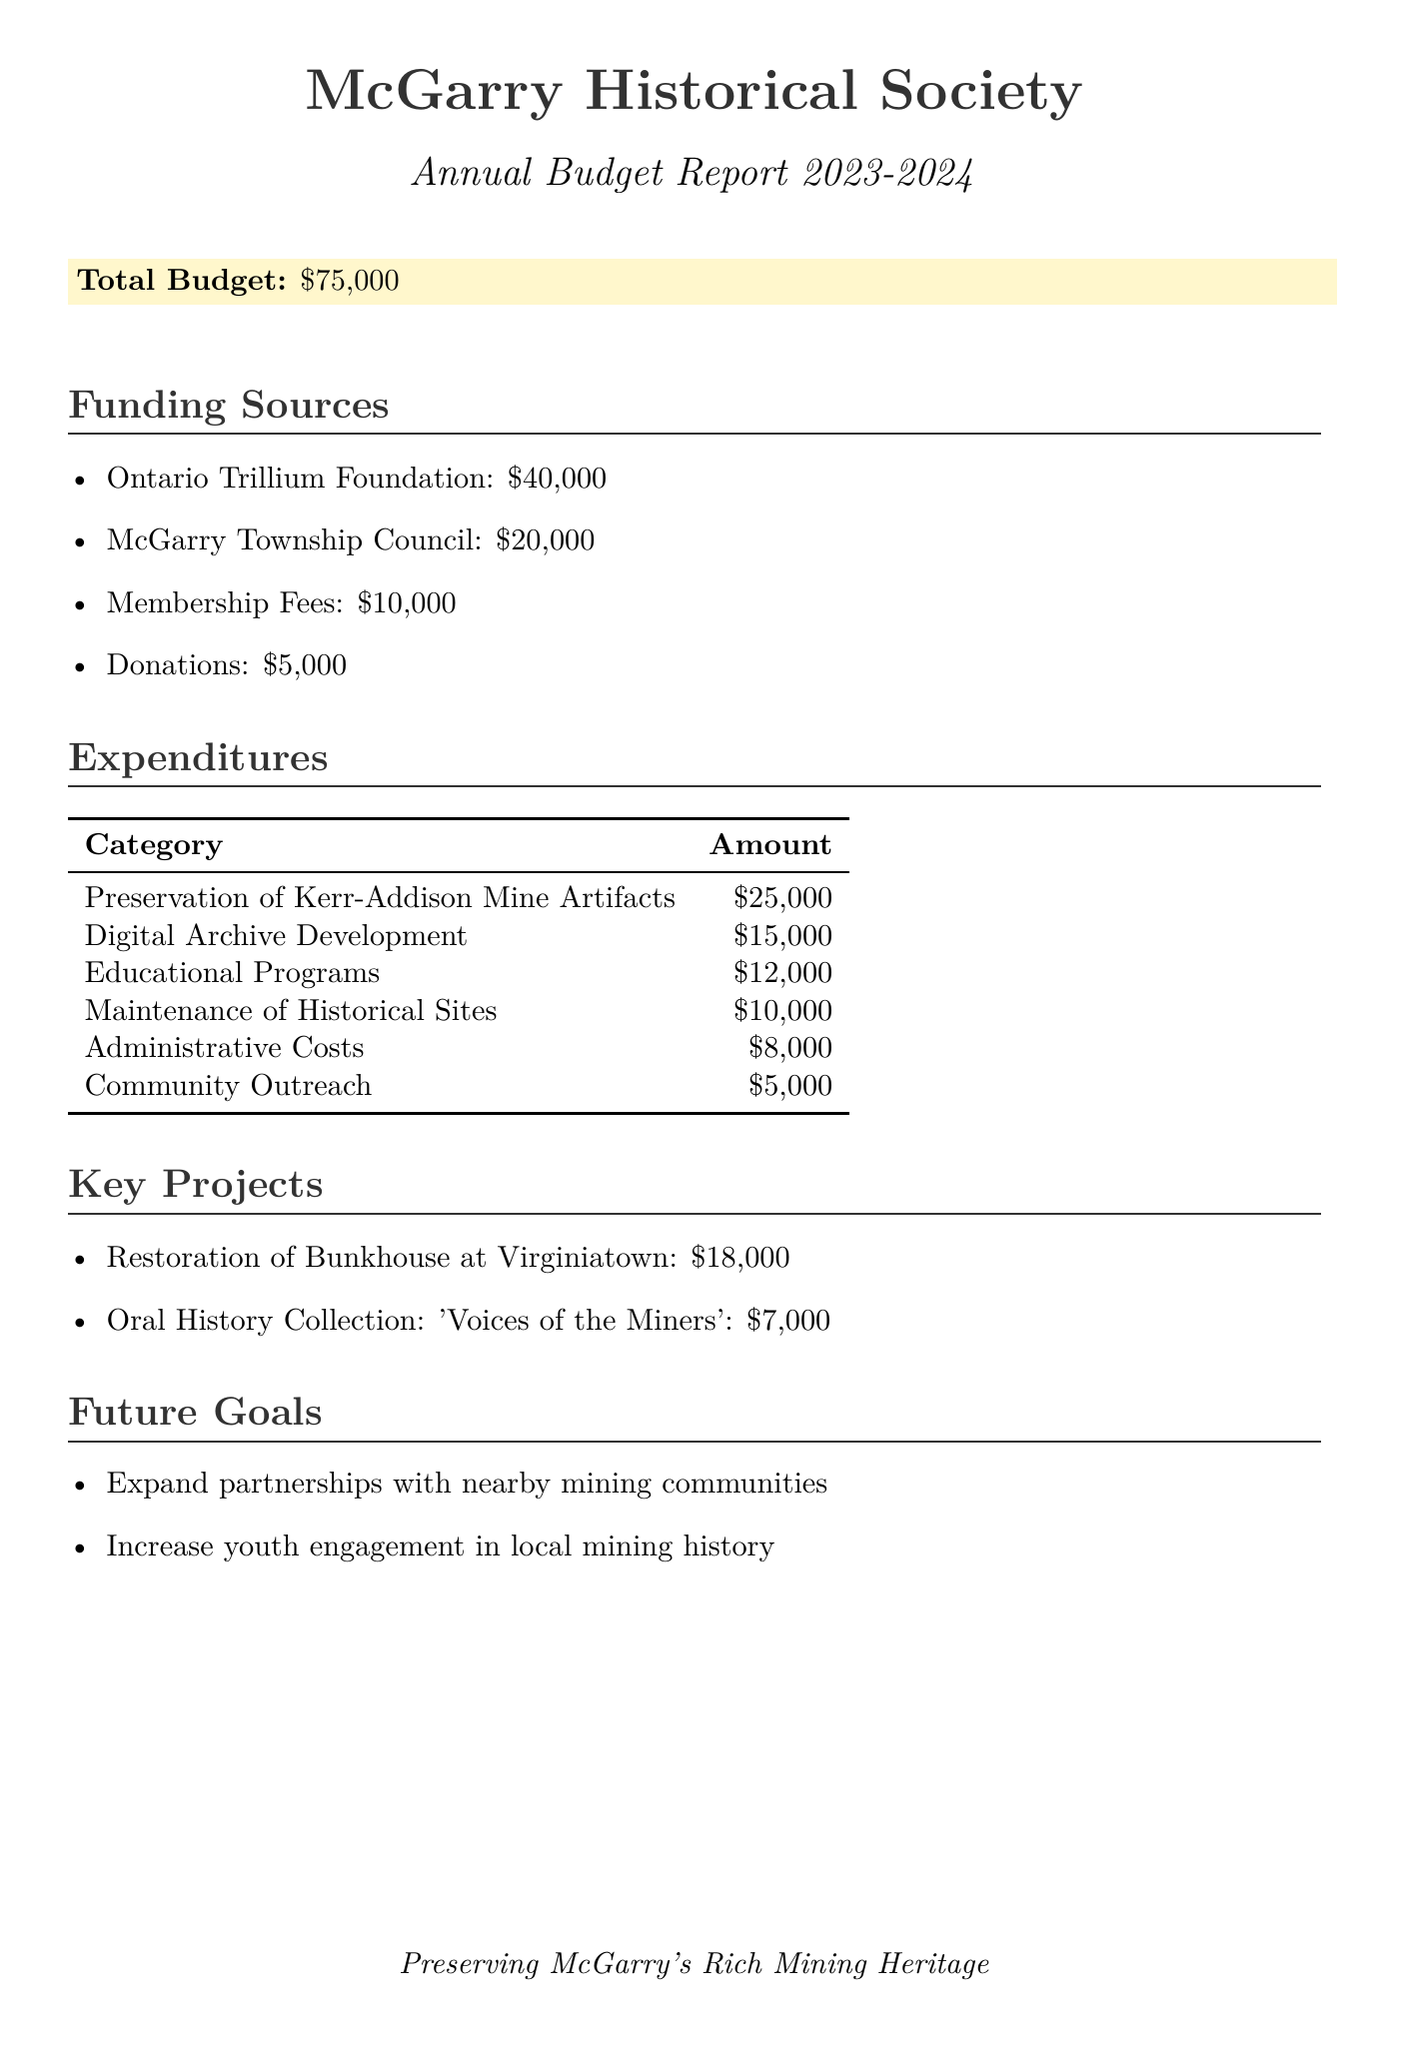What is the total budget? The total budget is stated at the beginning of the document as $75,000.
Answer: $75,000 How much does the Ontario Trillium Foundation contribute? The Ontario Trillium Foundation's contribution is detailed in the funding sources section.
Answer: $40,000 What is allocated for the Preservation of Kerr-Addison Mine Artifacts? The expenditure for preservation work can be found in the expenditures table.
Answer: $25,000 What is the budget for the restoration of the Bunkhouse at Virginiatown? This amount is specified under the key projects section in the document.
Answer: $18,000 How much is planned for Educational Programs? The amount for educational programs is listed in the expenditures section.
Answer: $12,000 What is one of the future goals mentioned? The future goals section includes goals aimed at enhancing local mining heritage engagement.
Answer: Expand partnerships with nearby mining communities How much is spent on administrative costs? The amount designated for administrative costs is highlighted in the expenditures.
Answer: $8,000 What is the total from Membership Fees? The funding source for Membership Fees is explicitly stated in the document.
Answer: $10,000 